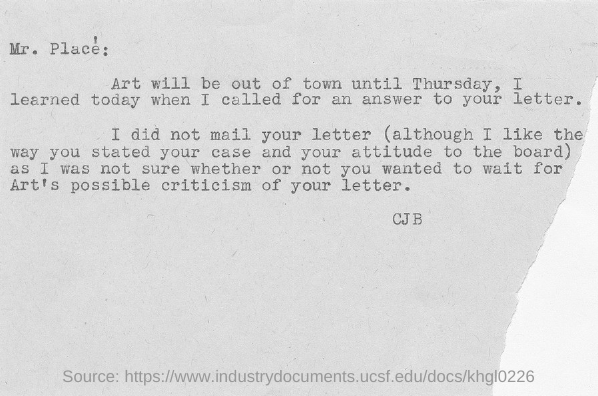"Art will be out of town until" which day?
Offer a very short reply. Thursday. Who wrote the letter?
Make the answer very short. CJB. 